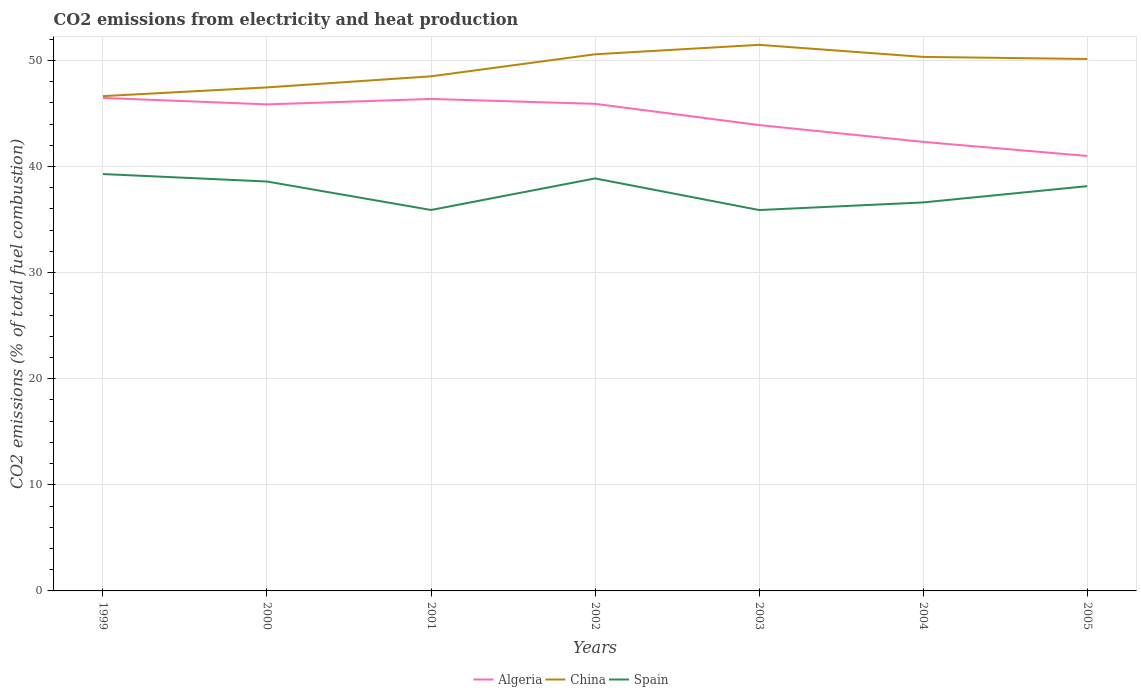How many different coloured lines are there?
Offer a terse response. 3. Across all years, what is the maximum amount of CO2 emitted in China?
Provide a short and direct response. 46.64. In which year was the amount of CO2 emitted in Spain maximum?
Make the answer very short. 2003. What is the total amount of CO2 emitted in China in the graph?
Offer a very short reply. -4.01. What is the difference between the highest and the second highest amount of CO2 emitted in Algeria?
Your response must be concise. 5.47. What is the difference between the highest and the lowest amount of CO2 emitted in China?
Your answer should be very brief. 4. Is the amount of CO2 emitted in China strictly greater than the amount of CO2 emitted in Spain over the years?
Make the answer very short. No. How many years are there in the graph?
Provide a short and direct response. 7. Does the graph contain any zero values?
Make the answer very short. No. Does the graph contain grids?
Make the answer very short. Yes. Where does the legend appear in the graph?
Your answer should be very brief. Bottom center. How many legend labels are there?
Ensure brevity in your answer.  3. How are the legend labels stacked?
Make the answer very short. Horizontal. What is the title of the graph?
Keep it short and to the point. CO2 emissions from electricity and heat production. Does "Moldova" appear as one of the legend labels in the graph?
Provide a succinct answer. No. What is the label or title of the X-axis?
Provide a short and direct response. Years. What is the label or title of the Y-axis?
Keep it short and to the point. CO2 emissions (% of total fuel combustion). What is the CO2 emissions (% of total fuel combustion) of Algeria in 1999?
Keep it short and to the point. 46.47. What is the CO2 emissions (% of total fuel combustion) of China in 1999?
Provide a short and direct response. 46.64. What is the CO2 emissions (% of total fuel combustion) of Spain in 1999?
Give a very brief answer. 39.29. What is the CO2 emissions (% of total fuel combustion) of Algeria in 2000?
Offer a terse response. 45.86. What is the CO2 emissions (% of total fuel combustion) in China in 2000?
Your answer should be very brief. 47.46. What is the CO2 emissions (% of total fuel combustion) of Spain in 2000?
Offer a very short reply. 38.59. What is the CO2 emissions (% of total fuel combustion) of Algeria in 2001?
Offer a very short reply. 46.37. What is the CO2 emissions (% of total fuel combustion) of China in 2001?
Offer a terse response. 48.5. What is the CO2 emissions (% of total fuel combustion) in Spain in 2001?
Provide a short and direct response. 35.91. What is the CO2 emissions (% of total fuel combustion) of Algeria in 2002?
Provide a short and direct response. 45.91. What is the CO2 emissions (% of total fuel combustion) of China in 2002?
Keep it short and to the point. 50.58. What is the CO2 emissions (% of total fuel combustion) in Spain in 2002?
Your answer should be very brief. 38.88. What is the CO2 emissions (% of total fuel combustion) in Algeria in 2003?
Provide a succinct answer. 43.91. What is the CO2 emissions (% of total fuel combustion) of China in 2003?
Give a very brief answer. 51.47. What is the CO2 emissions (% of total fuel combustion) of Spain in 2003?
Give a very brief answer. 35.9. What is the CO2 emissions (% of total fuel combustion) of Algeria in 2004?
Ensure brevity in your answer.  42.32. What is the CO2 emissions (% of total fuel combustion) in China in 2004?
Offer a terse response. 50.33. What is the CO2 emissions (% of total fuel combustion) of Spain in 2004?
Your response must be concise. 36.62. What is the CO2 emissions (% of total fuel combustion) in Algeria in 2005?
Your answer should be compact. 41. What is the CO2 emissions (% of total fuel combustion) of China in 2005?
Ensure brevity in your answer.  50.14. What is the CO2 emissions (% of total fuel combustion) in Spain in 2005?
Give a very brief answer. 38.15. Across all years, what is the maximum CO2 emissions (% of total fuel combustion) in Algeria?
Your response must be concise. 46.47. Across all years, what is the maximum CO2 emissions (% of total fuel combustion) of China?
Offer a terse response. 51.47. Across all years, what is the maximum CO2 emissions (% of total fuel combustion) of Spain?
Make the answer very short. 39.29. Across all years, what is the minimum CO2 emissions (% of total fuel combustion) in Algeria?
Keep it short and to the point. 41. Across all years, what is the minimum CO2 emissions (% of total fuel combustion) in China?
Provide a short and direct response. 46.64. Across all years, what is the minimum CO2 emissions (% of total fuel combustion) of Spain?
Give a very brief answer. 35.9. What is the total CO2 emissions (% of total fuel combustion) of Algeria in the graph?
Make the answer very short. 311.84. What is the total CO2 emissions (% of total fuel combustion) in China in the graph?
Offer a terse response. 345.13. What is the total CO2 emissions (% of total fuel combustion) of Spain in the graph?
Ensure brevity in your answer.  263.34. What is the difference between the CO2 emissions (% of total fuel combustion) in Algeria in 1999 and that in 2000?
Offer a very short reply. 0.61. What is the difference between the CO2 emissions (% of total fuel combustion) of China in 1999 and that in 2000?
Offer a terse response. -0.82. What is the difference between the CO2 emissions (% of total fuel combustion) in Spain in 1999 and that in 2000?
Provide a short and direct response. 0.7. What is the difference between the CO2 emissions (% of total fuel combustion) in Algeria in 1999 and that in 2001?
Your answer should be very brief. 0.1. What is the difference between the CO2 emissions (% of total fuel combustion) of China in 1999 and that in 2001?
Provide a short and direct response. -1.87. What is the difference between the CO2 emissions (% of total fuel combustion) of Spain in 1999 and that in 2001?
Your response must be concise. 3.39. What is the difference between the CO2 emissions (% of total fuel combustion) in Algeria in 1999 and that in 2002?
Your answer should be compact. 0.56. What is the difference between the CO2 emissions (% of total fuel combustion) in China in 1999 and that in 2002?
Ensure brevity in your answer.  -3.94. What is the difference between the CO2 emissions (% of total fuel combustion) of Spain in 1999 and that in 2002?
Your response must be concise. 0.41. What is the difference between the CO2 emissions (% of total fuel combustion) of Algeria in 1999 and that in 2003?
Your answer should be very brief. 2.56. What is the difference between the CO2 emissions (% of total fuel combustion) in China in 1999 and that in 2003?
Your answer should be very brief. -4.83. What is the difference between the CO2 emissions (% of total fuel combustion) in Spain in 1999 and that in 2003?
Give a very brief answer. 3.39. What is the difference between the CO2 emissions (% of total fuel combustion) of Algeria in 1999 and that in 2004?
Make the answer very short. 4.14. What is the difference between the CO2 emissions (% of total fuel combustion) in China in 1999 and that in 2004?
Provide a short and direct response. -3.7. What is the difference between the CO2 emissions (% of total fuel combustion) in Spain in 1999 and that in 2004?
Provide a short and direct response. 2.67. What is the difference between the CO2 emissions (% of total fuel combustion) of Algeria in 1999 and that in 2005?
Keep it short and to the point. 5.47. What is the difference between the CO2 emissions (% of total fuel combustion) of China in 1999 and that in 2005?
Provide a succinct answer. -3.5. What is the difference between the CO2 emissions (% of total fuel combustion) in Spain in 1999 and that in 2005?
Keep it short and to the point. 1.14. What is the difference between the CO2 emissions (% of total fuel combustion) of Algeria in 2000 and that in 2001?
Provide a short and direct response. -0.51. What is the difference between the CO2 emissions (% of total fuel combustion) in China in 2000 and that in 2001?
Give a very brief answer. -1.04. What is the difference between the CO2 emissions (% of total fuel combustion) of Spain in 2000 and that in 2001?
Offer a very short reply. 2.68. What is the difference between the CO2 emissions (% of total fuel combustion) in Algeria in 2000 and that in 2002?
Your answer should be compact. -0.05. What is the difference between the CO2 emissions (% of total fuel combustion) of China in 2000 and that in 2002?
Your response must be concise. -3.12. What is the difference between the CO2 emissions (% of total fuel combustion) of Spain in 2000 and that in 2002?
Your response must be concise. -0.29. What is the difference between the CO2 emissions (% of total fuel combustion) of Algeria in 2000 and that in 2003?
Provide a short and direct response. 1.95. What is the difference between the CO2 emissions (% of total fuel combustion) of China in 2000 and that in 2003?
Offer a terse response. -4.01. What is the difference between the CO2 emissions (% of total fuel combustion) in Spain in 2000 and that in 2003?
Your answer should be compact. 2.69. What is the difference between the CO2 emissions (% of total fuel combustion) in Algeria in 2000 and that in 2004?
Ensure brevity in your answer.  3.53. What is the difference between the CO2 emissions (% of total fuel combustion) in China in 2000 and that in 2004?
Offer a terse response. -2.87. What is the difference between the CO2 emissions (% of total fuel combustion) of Spain in 2000 and that in 2004?
Your answer should be very brief. 1.97. What is the difference between the CO2 emissions (% of total fuel combustion) in Algeria in 2000 and that in 2005?
Keep it short and to the point. 4.86. What is the difference between the CO2 emissions (% of total fuel combustion) in China in 2000 and that in 2005?
Keep it short and to the point. -2.68. What is the difference between the CO2 emissions (% of total fuel combustion) of Spain in 2000 and that in 2005?
Your answer should be very brief. 0.44. What is the difference between the CO2 emissions (% of total fuel combustion) of Algeria in 2001 and that in 2002?
Ensure brevity in your answer.  0.46. What is the difference between the CO2 emissions (% of total fuel combustion) in China in 2001 and that in 2002?
Keep it short and to the point. -2.08. What is the difference between the CO2 emissions (% of total fuel combustion) in Spain in 2001 and that in 2002?
Give a very brief answer. -2.98. What is the difference between the CO2 emissions (% of total fuel combustion) in Algeria in 2001 and that in 2003?
Offer a very short reply. 2.46. What is the difference between the CO2 emissions (% of total fuel combustion) in China in 2001 and that in 2003?
Keep it short and to the point. -2.97. What is the difference between the CO2 emissions (% of total fuel combustion) in Spain in 2001 and that in 2003?
Give a very brief answer. 0. What is the difference between the CO2 emissions (% of total fuel combustion) in Algeria in 2001 and that in 2004?
Keep it short and to the point. 4.05. What is the difference between the CO2 emissions (% of total fuel combustion) in China in 2001 and that in 2004?
Offer a very short reply. -1.83. What is the difference between the CO2 emissions (% of total fuel combustion) in Spain in 2001 and that in 2004?
Your response must be concise. -0.71. What is the difference between the CO2 emissions (% of total fuel combustion) of Algeria in 2001 and that in 2005?
Your answer should be compact. 5.37. What is the difference between the CO2 emissions (% of total fuel combustion) in China in 2001 and that in 2005?
Provide a succinct answer. -1.64. What is the difference between the CO2 emissions (% of total fuel combustion) of Spain in 2001 and that in 2005?
Provide a short and direct response. -2.25. What is the difference between the CO2 emissions (% of total fuel combustion) of Algeria in 2002 and that in 2003?
Give a very brief answer. 2. What is the difference between the CO2 emissions (% of total fuel combustion) in China in 2002 and that in 2003?
Give a very brief answer. -0.89. What is the difference between the CO2 emissions (% of total fuel combustion) of Spain in 2002 and that in 2003?
Give a very brief answer. 2.98. What is the difference between the CO2 emissions (% of total fuel combustion) of Algeria in 2002 and that in 2004?
Your response must be concise. 3.59. What is the difference between the CO2 emissions (% of total fuel combustion) in China in 2002 and that in 2004?
Ensure brevity in your answer.  0.25. What is the difference between the CO2 emissions (% of total fuel combustion) in Spain in 2002 and that in 2004?
Offer a terse response. 2.26. What is the difference between the CO2 emissions (% of total fuel combustion) of Algeria in 2002 and that in 2005?
Provide a succinct answer. 4.91. What is the difference between the CO2 emissions (% of total fuel combustion) of China in 2002 and that in 2005?
Your answer should be very brief. 0.44. What is the difference between the CO2 emissions (% of total fuel combustion) of Spain in 2002 and that in 2005?
Provide a short and direct response. 0.73. What is the difference between the CO2 emissions (% of total fuel combustion) in Algeria in 2003 and that in 2004?
Offer a very short reply. 1.58. What is the difference between the CO2 emissions (% of total fuel combustion) of China in 2003 and that in 2004?
Ensure brevity in your answer.  1.14. What is the difference between the CO2 emissions (% of total fuel combustion) in Spain in 2003 and that in 2004?
Your answer should be compact. -0.72. What is the difference between the CO2 emissions (% of total fuel combustion) of Algeria in 2003 and that in 2005?
Provide a short and direct response. 2.91. What is the difference between the CO2 emissions (% of total fuel combustion) in China in 2003 and that in 2005?
Ensure brevity in your answer.  1.33. What is the difference between the CO2 emissions (% of total fuel combustion) of Spain in 2003 and that in 2005?
Ensure brevity in your answer.  -2.25. What is the difference between the CO2 emissions (% of total fuel combustion) in Algeria in 2004 and that in 2005?
Offer a terse response. 1.33. What is the difference between the CO2 emissions (% of total fuel combustion) in China in 2004 and that in 2005?
Ensure brevity in your answer.  0.19. What is the difference between the CO2 emissions (% of total fuel combustion) in Spain in 2004 and that in 2005?
Offer a very short reply. -1.53. What is the difference between the CO2 emissions (% of total fuel combustion) in Algeria in 1999 and the CO2 emissions (% of total fuel combustion) in China in 2000?
Provide a succinct answer. -0.99. What is the difference between the CO2 emissions (% of total fuel combustion) in Algeria in 1999 and the CO2 emissions (% of total fuel combustion) in Spain in 2000?
Provide a succinct answer. 7.88. What is the difference between the CO2 emissions (% of total fuel combustion) in China in 1999 and the CO2 emissions (% of total fuel combustion) in Spain in 2000?
Make the answer very short. 8.05. What is the difference between the CO2 emissions (% of total fuel combustion) of Algeria in 1999 and the CO2 emissions (% of total fuel combustion) of China in 2001?
Offer a very short reply. -2.04. What is the difference between the CO2 emissions (% of total fuel combustion) in Algeria in 1999 and the CO2 emissions (% of total fuel combustion) in Spain in 2001?
Your answer should be compact. 10.56. What is the difference between the CO2 emissions (% of total fuel combustion) of China in 1999 and the CO2 emissions (% of total fuel combustion) of Spain in 2001?
Offer a very short reply. 10.73. What is the difference between the CO2 emissions (% of total fuel combustion) in Algeria in 1999 and the CO2 emissions (% of total fuel combustion) in China in 2002?
Make the answer very short. -4.11. What is the difference between the CO2 emissions (% of total fuel combustion) in Algeria in 1999 and the CO2 emissions (% of total fuel combustion) in Spain in 2002?
Provide a short and direct response. 7.59. What is the difference between the CO2 emissions (% of total fuel combustion) of China in 1999 and the CO2 emissions (% of total fuel combustion) of Spain in 2002?
Make the answer very short. 7.76. What is the difference between the CO2 emissions (% of total fuel combustion) in Algeria in 1999 and the CO2 emissions (% of total fuel combustion) in China in 2003?
Offer a very short reply. -5. What is the difference between the CO2 emissions (% of total fuel combustion) of Algeria in 1999 and the CO2 emissions (% of total fuel combustion) of Spain in 2003?
Provide a short and direct response. 10.57. What is the difference between the CO2 emissions (% of total fuel combustion) in China in 1999 and the CO2 emissions (% of total fuel combustion) in Spain in 2003?
Make the answer very short. 10.74. What is the difference between the CO2 emissions (% of total fuel combustion) of Algeria in 1999 and the CO2 emissions (% of total fuel combustion) of China in 2004?
Provide a short and direct response. -3.87. What is the difference between the CO2 emissions (% of total fuel combustion) of Algeria in 1999 and the CO2 emissions (% of total fuel combustion) of Spain in 2004?
Make the answer very short. 9.85. What is the difference between the CO2 emissions (% of total fuel combustion) in China in 1999 and the CO2 emissions (% of total fuel combustion) in Spain in 2004?
Make the answer very short. 10.02. What is the difference between the CO2 emissions (% of total fuel combustion) in Algeria in 1999 and the CO2 emissions (% of total fuel combustion) in China in 2005?
Keep it short and to the point. -3.67. What is the difference between the CO2 emissions (% of total fuel combustion) of Algeria in 1999 and the CO2 emissions (% of total fuel combustion) of Spain in 2005?
Your answer should be compact. 8.31. What is the difference between the CO2 emissions (% of total fuel combustion) in China in 1999 and the CO2 emissions (% of total fuel combustion) in Spain in 2005?
Your answer should be very brief. 8.48. What is the difference between the CO2 emissions (% of total fuel combustion) in Algeria in 2000 and the CO2 emissions (% of total fuel combustion) in China in 2001?
Your response must be concise. -2.64. What is the difference between the CO2 emissions (% of total fuel combustion) of Algeria in 2000 and the CO2 emissions (% of total fuel combustion) of Spain in 2001?
Make the answer very short. 9.95. What is the difference between the CO2 emissions (% of total fuel combustion) in China in 2000 and the CO2 emissions (% of total fuel combustion) in Spain in 2001?
Your answer should be compact. 11.56. What is the difference between the CO2 emissions (% of total fuel combustion) of Algeria in 2000 and the CO2 emissions (% of total fuel combustion) of China in 2002?
Give a very brief answer. -4.72. What is the difference between the CO2 emissions (% of total fuel combustion) in Algeria in 2000 and the CO2 emissions (% of total fuel combustion) in Spain in 2002?
Offer a terse response. 6.98. What is the difference between the CO2 emissions (% of total fuel combustion) in China in 2000 and the CO2 emissions (% of total fuel combustion) in Spain in 2002?
Make the answer very short. 8.58. What is the difference between the CO2 emissions (% of total fuel combustion) of Algeria in 2000 and the CO2 emissions (% of total fuel combustion) of China in 2003?
Keep it short and to the point. -5.61. What is the difference between the CO2 emissions (% of total fuel combustion) in Algeria in 2000 and the CO2 emissions (% of total fuel combustion) in Spain in 2003?
Your response must be concise. 9.96. What is the difference between the CO2 emissions (% of total fuel combustion) of China in 2000 and the CO2 emissions (% of total fuel combustion) of Spain in 2003?
Your response must be concise. 11.56. What is the difference between the CO2 emissions (% of total fuel combustion) in Algeria in 2000 and the CO2 emissions (% of total fuel combustion) in China in 2004?
Offer a terse response. -4.47. What is the difference between the CO2 emissions (% of total fuel combustion) in Algeria in 2000 and the CO2 emissions (% of total fuel combustion) in Spain in 2004?
Your answer should be very brief. 9.24. What is the difference between the CO2 emissions (% of total fuel combustion) of China in 2000 and the CO2 emissions (% of total fuel combustion) of Spain in 2004?
Offer a very short reply. 10.84. What is the difference between the CO2 emissions (% of total fuel combustion) of Algeria in 2000 and the CO2 emissions (% of total fuel combustion) of China in 2005?
Make the answer very short. -4.28. What is the difference between the CO2 emissions (% of total fuel combustion) in Algeria in 2000 and the CO2 emissions (% of total fuel combustion) in Spain in 2005?
Keep it short and to the point. 7.71. What is the difference between the CO2 emissions (% of total fuel combustion) of China in 2000 and the CO2 emissions (% of total fuel combustion) of Spain in 2005?
Your response must be concise. 9.31. What is the difference between the CO2 emissions (% of total fuel combustion) of Algeria in 2001 and the CO2 emissions (% of total fuel combustion) of China in 2002?
Provide a succinct answer. -4.21. What is the difference between the CO2 emissions (% of total fuel combustion) in Algeria in 2001 and the CO2 emissions (% of total fuel combustion) in Spain in 2002?
Your answer should be very brief. 7.49. What is the difference between the CO2 emissions (% of total fuel combustion) of China in 2001 and the CO2 emissions (% of total fuel combustion) of Spain in 2002?
Your answer should be compact. 9.62. What is the difference between the CO2 emissions (% of total fuel combustion) of Algeria in 2001 and the CO2 emissions (% of total fuel combustion) of China in 2003?
Give a very brief answer. -5.1. What is the difference between the CO2 emissions (% of total fuel combustion) in Algeria in 2001 and the CO2 emissions (% of total fuel combustion) in Spain in 2003?
Your answer should be compact. 10.47. What is the difference between the CO2 emissions (% of total fuel combustion) of China in 2001 and the CO2 emissions (% of total fuel combustion) of Spain in 2003?
Offer a terse response. 12.6. What is the difference between the CO2 emissions (% of total fuel combustion) in Algeria in 2001 and the CO2 emissions (% of total fuel combustion) in China in 2004?
Ensure brevity in your answer.  -3.96. What is the difference between the CO2 emissions (% of total fuel combustion) of Algeria in 2001 and the CO2 emissions (% of total fuel combustion) of Spain in 2004?
Your answer should be compact. 9.75. What is the difference between the CO2 emissions (% of total fuel combustion) of China in 2001 and the CO2 emissions (% of total fuel combustion) of Spain in 2004?
Keep it short and to the point. 11.89. What is the difference between the CO2 emissions (% of total fuel combustion) of Algeria in 2001 and the CO2 emissions (% of total fuel combustion) of China in 2005?
Your answer should be compact. -3.77. What is the difference between the CO2 emissions (% of total fuel combustion) of Algeria in 2001 and the CO2 emissions (% of total fuel combustion) of Spain in 2005?
Make the answer very short. 8.22. What is the difference between the CO2 emissions (% of total fuel combustion) in China in 2001 and the CO2 emissions (% of total fuel combustion) in Spain in 2005?
Keep it short and to the point. 10.35. What is the difference between the CO2 emissions (% of total fuel combustion) in Algeria in 2002 and the CO2 emissions (% of total fuel combustion) in China in 2003?
Make the answer very short. -5.56. What is the difference between the CO2 emissions (% of total fuel combustion) in Algeria in 2002 and the CO2 emissions (% of total fuel combustion) in Spain in 2003?
Offer a terse response. 10.01. What is the difference between the CO2 emissions (% of total fuel combustion) of China in 2002 and the CO2 emissions (% of total fuel combustion) of Spain in 2003?
Provide a short and direct response. 14.68. What is the difference between the CO2 emissions (% of total fuel combustion) of Algeria in 2002 and the CO2 emissions (% of total fuel combustion) of China in 2004?
Give a very brief answer. -4.42. What is the difference between the CO2 emissions (% of total fuel combustion) of Algeria in 2002 and the CO2 emissions (% of total fuel combustion) of Spain in 2004?
Your answer should be very brief. 9.29. What is the difference between the CO2 emissions (% of total fuel combustion) of China in 2002 and the CO2 emissions (% of total fuel combustion) of Spain in 2004?
Ensure brevity in your answer.  13.96. What is the difference between the CO2 emissions (% of total fuel combustion) of Algeria in 2002 and the CO2 emissions (% of total fuel combustion) of China in 2005?
Offer a very short reply. -4.23. What is the difference between the CO2 emissions (% of total fuel combustion) of Algeria in 2002 and the CO2 emissions (% of total fuel combustion) of Spain in 2005?
Your answer should be very brief. 7.76. What is the difference between the CO2 emissions (% of total fuel combustion) in China in 2002 and the CO2 emissions (% of total fuel combustion) in Spain in 2005?
Your answer should be compact. 12.43. What is the difference between the CO2 emissions (% of total fuel combustion) in Algeria in 2003 and the CO2 emissions (% of total fuel combustion) in China in 2004?
Your answer should be compact. -6.42. What is the difference between the CO2 emissions (% of total fuel combustion) of Algeria in 2003 and the CO2 emissions (% of total fuel combustion) of Spain in 2004?
Provide a succinct answer. 7.29. What is the difference between the CO2 emissions (% of total fuel combustion) in China in 2003 and the CO2 emissions (% of total fuel combustion) in Spain in 2004?
Your response must be concise. 14.85. What is the difference between the CO2 emissions (% of total fuel combustion) in Algeria in 2003 and the CO2 emissions (% of total fuel combustion) in China in 2005?
Your response must be concise. -6.23. What is the difference between the CO2 emissions (% of total fuel combustion) of Algeria in 2003 and the CO2 emissions (% of total fuel combustion) of Spain in 2005?
Your answer should be very brief. 5.76. What is the difference between the CO2 emissions (% of total fuel combustion) in China in 2003 and the CO2 emissions (% of total fuel combustion) in Spain in 2005?
Keep it short and to the point. 13.32. What is the difference between the CO2 emissions (% of total fuel combustion) of Algeria in 2004 and the CO2 emissions (% of total fuel combustion) of China in 2005?
Your answer should be very brief. -7.82. What is the difference between the CO2 emissions (% of total fuel combustion) in Algeria in 2004 and the CO2 emissions (% of total fuel combustion) in Spain in 2005?
Offer a terse response. 4.17. What is the difference between the CO2 emissions (% of total fuel combustion) of China in 2004 and the CO2 emissions (% of total fuel combustion) of Spain in 2005?
Make the answer very short. 12.18. What is the average CO2 emissions (% of total fuel combustion) in Algeria per year?
Give a very brief answer. 44.55. What is the average CO2 emissions (% of total fuel combustion) in China per year?
Make the answer very short. 49.3. What is the average CO2 emissions (% of total fuel combustion) of Spain per year?
Your response must be concise. 37.62. In the year 1999, what is the difference between the CO2 emissions (% of total fuel combustion) in Algeria and CO2 emissions (% of total fuel combustion) in China?
Your response must be concise. -0.17. In the year 1999, what is the difference between the CO2 emissions (% of total fuel combustion) in Algeria and CO2 emissions (% of total fuel combustion) in Spain?
Offer a terse response. 7.17. In the year 1999, what is the difference between the CO2 emissions (% of total fuel combustion) of China and CO2 emissions (% of total fuel combustion) of Spain?
Your response must be concise. 7.34. In the year 2000, what is the difference between the CO2 emissions (% of total fuel combustion) of Algeria and CO2 emissions (% of total fuel combustion) of China?
Ensure brevity in your answer.  -1.6. In the year 2000, what is the difference between the CO2 emissions (% of total fuel combustion) of Algeria and CO2 emissions (% of total fuel combustion) of Spain?
Provide a succinct answer. 7.27. In the year 2000, what is the difference between the CO2 emissions (% of total fuel combustion) in China and CO2 emissions (% of total fuel combustion) in Spain?
Provide a short and direct response. 8.87. In the year 2001, what is the difference between the CO2 emissions (% of total fuel combustion) in Algeria and CO2 emissions (% of total fuel combustion) in China?
Ensure brevity in your answer.  -2.13. In the year 2001, what is the difference between the CO2 emissions (% of total fuel combustion) in Algeria and CO2 emissions (% of total fuel combustion) in Spain?
Provide a short and direct response. 10.47. In the year 2001, what is the difference between the CO2 emissions (% of total fuel combustion) of China and CO2 emissions (% of total fuel combustion) of Spain?
Offer a terse response. 12.6. In the year 2002, what is the difference between the CO2 emissions (% of total fuel combustion) of Algeria and CO2 emissions (% of total fuel combustion) of China?
Your answer should be very brief. -4.67. In the year 2002, what is the difference between the CO2 emissions (% of total fuel combustion) of Algeria and CO2 emissions (% of total fuel combustion) of Spain?
Provide a short and direct response. 7.03. In the year 2002, what is the difference between the CO2 emissions (% of total fuel combustion) of China and CO2 emissions (% of total fuel combustion) of Spain?
Ensure brevity in your answer.  11.7. In the year 2003, what is the difference between the CO2 emissions (% of total fuel combustion) in Algeria and CO2 emissions (% of total fuel combustion) in China?
Your answer should be compact. -7.56. In the year 2003, what is the difference between the CO2 emissions (% of total fuel combustion) of Algeria and CO2 emissions (% of total fuel combustion) of Spain?
Your answer should be compact. 8.01. In the year 2003, what is the difference between the CO2 emissions (% of total fuel combustion) of China and CO2 emissions (% of total fuel combustion) of Spain?
Your answer should be very brief. 15.57. In the year 2004, what is the difference between the CO2 emissions (% of total fuel combustion) in Algeria and CO2 emissions (% of total fuel combustion) in China?
Provide a succinct answer. -8.01. In the year 2004, what is the difference between the CO2 emissions (% of total fuel combustion) of Algeria and CO2 emissions (% of total fuel combustion) of Spain?
Keep it short and to the point. 5.71. In the year 2004, what is the difference between the CO2 emissions (% of total fuel combustion) of China and CO2 emissions (% of total fuel combustion) of Spain?
Provide a short and direct response. 13.71. In the year 2005, what is the difference between the CO2 emissions (% of total fuel combustion) of Algeria and CO2 emissions (% of total fuel combustion) of China?
Offer a very short reply. -9.14. In the year 2005, what is the difference between the CO2 emissions (% of total fuel combustion) of Algeria and CO2 emissions (% of total fuel combustion) of Spain?
Your answer should be very brief. 2.85. In the year 2005, what is the difference between the CO2 emissions (% of total fuel combustion) of China and CO2 emissions (% of total fuel combustion) of Spain?
Keep it short and to the point. 11.99. What is the ratio of the CO2 emissions (% of total fuel combustion) of Algeria in 1999 to that in 2000?
Give a very brief answer. 1.01. What is the ratio of the CO2 emissions (% of total fuel combustion) of China in 1999 to that in 2000?
Offer a very short reply. 0.98. What is the ratio of the CO2 emissions (% of total fuel combustion) of Spain in 1999 to that in 2000?
Offer a terse response. 1.02. What is the ratio of the CO2 emissions (% of total fuel combustion) in Algeria in 1999 to that in 2001?
Provide a short and direct response. 1. What is the ratio of the CO2 emissions (% of total fuel combustion) of China in 1999 to that in 2001?
Give a very brief answer. 0.96. What is the ratio of the CO2 emissions (% of total fuel combustion) of Spain in 1999 to that in 2001?
Ensure brevity in your answer.  1.09. What is the ratio of the CO2 emissions (% of total fuel combustion) of Algeria in 1999 to that in 2002?
Your answer should be very brief. 1.01. What is the ratio of the CO2 emissions (% of total fuel combustion) of China in 1999 to that in 2002?
Offer a terse response. 0.92. What is the ratio of the CO2 emissions (% of total fuel combustion) in Spain in 1999 to that in 2002?
Provide a succinct answer. 1.01. What is the ratio of the CO2 emissions (% of total fuel combustion) in Algeria in 1999 to that in 2003?
Provide a succinct answer. 1.06. What is the ratio of the CO2 emissions (% of total fuel combustion) in China in 1999 to that in 2003?
Offer a terse response. 0.91. What is the ratio of the CO2 emissions (% of total fuel combustion) in Spain in 1999 to that in 2003?
Provide a short and direct response. 1.09. What is the ratio of the CO2 emissions (% of total fuel combustion) of Algeria in 1999 to that in 2004?
Provide a succinct answer. 1.1. What is the ratio of the CO2 emissions (% of total fuel combustion) of China in 1999 to that in 2004?
Your answer should be compact. 0.93. What is the ratio of the CO2 emissions (% of total fuel combustion) of Spain in 1999 to that in 2004?
Keep it short and to the point. 1.07. What is the ratio of the CO2 emissions (% of total fuel combustion) of Algeria in 1999 to that in 2005?
Ensure brevity in your answer.  1.13. What is the ratio of the CO2 emissions (% of total fuel combustion) in China in 1999 to that in 2005?
Your answer should be compact. 0.93. What is the ratio of the CO2 emissions (% of total fuel combustion) of Spain in 1999 to that in 2005?
Your answer should be compact. 1.03. What is the ratio of the CO2 emissions (% of total fuel combustion) in China in 2000 to that in 2001?
Make the answer very short. 0.98. What is the ratio of the CO2 emissions (% of total fuel combustion) in Spain in 2000 to that in 2001?
Offer a very short reply. 1.07. What is the ratio of the CO2 emissions (% of total fuel combustion) of Algeria in 2000 to that in 2002?
Your response must be concise. 1. What is the ratio of the CO2 emissions (% of total fuel combustion) in China in 2000 to that in 2002?
Your answer should be compact. 0.94. What is the ratio of the CO2 emissions (% of total fuel combustion) of Spain in 2000 to that in 2002?
Provide a short and direct response. 0.99. What is the ratio of the CO2 emissions (% of total fuel combustion) in Algeria in 2000 to that in 2003?
Your response must be concise. 1.04. What is the ratio of the CO2 emissions (% of total fuel combustion) of China in 2000 to that in 2003?
Provide a short and direct response. 0.92. What is the ratio of the CO2 emissions (% of total fuel combustion) in Spain in 2000 to that in 2003?
Give a very brief answer. 1.07. What is the ratio of the CO2 emissions (% of total fuel combustion) in Algeria in 2000 to that in 2004?
Your answer should be compact. 1.08. What is the ratio of the CO2 emissions (% of total fuel combustion) in China in 2000 to that in 2004?
Offer a terse response. 0.94. What is the ratio of the CO2 emissions (% of total fuel combustion) in Spain in 2000 to that in 2004?
Keep it short and to the point. 1.05. What is the ratio of the CO2 emissions (% of total fuel combustion) of Algeria in 2000 to that in 2005?
Your answer should be very brief. 1.12. What is the ratio of the CO2 emissions (% of total fuel combustion) of China in 2000 to that in 2005?
Your answer should be very brief. 0.95. What is the ratio of the CO2 emissions (% of total fuel combustion) of Spain in 2000 to that in 2005?
Provide a succinct answer. 1.01. What is the ratio of the CO2 emissions (% of total fuel combustion) in Algeria in 2001 to that in 2002?
Offer a very short reply. 1.01. What is the ratio of the CO2 emissions (% of total fuel combustion) in China in 2001 to that in 2002?
Offer a terse response. 0.96. What is the ratio of the CO2 emissions (% of total fuel combustion) of Spain in 2001 to that in 2002?
Keep it short and to the point. 0.92. What is the ratio of the CO2 emissions (% of total fuel combustion) in Algeria in 2001 to that in 2003?
Provide a short and direct response. 1.06. What is the ratio of the CO2 emissions (% of total fuel combustion) of China in 2001 to that in 2003?
Offer a very short reply. 0.94. What is the ratio of the CO2 emissions (% of total fuel combustion) of Algeria in 2001 to that in 2004?
Your response must be concise. 1.1. What is the ratio of the CO2 emissions (% of total fuel combustion) in China in 2001 to that in 2004?
Your response must be concise. 0.96. What is the ratio of the CO2 emissions (% of total fuel combustion) in Spain in 2001 to that in 2004?
Your response must be concise. 0.98. What is the ratio of the CO2 emissions (% of total fuel combustion) in Algeria in 2001 to that in 2005?
Your answer should be very brief. 1.13. What is the ratio of the CO2 emissions (% of total fuel combustion) of China in 2001 to that in 2005?
Your response must be concise. 0.97. What is the ratio of the CO2 emissions (% of total fuel combustion) in Spain in 2001 to that in 2005?
Make the answer very short. 0.94. What is the ratio of the CO2 emissions (% of total fuel combustion) in Algeria in 2002 to that in 2003?
Provide a short and direct response. 1.05. What is the ratio of the CO2 emissions (% of total fuel combustion) in China in 2002 to that in 2003?
Keep it short and to the point. 0.98. What is the ratio of the CO2 emissions (% of total fuel combustion) in Spain in 2002 to that in 2003?
Your answer should be compact. 1.08. What is the ratio of the CO2 emissions (% of total fuel combustion) in Algeria in 2002 to that in 2004?
Keep it short and to the point. 1.08. What is the ratio of the CO2 emissions (% of total fuel combustion) in Spain in 2002 to that in 2004?
Offer a very short reply. 1.06. What is the ratio of the CO2 emissions (% of total fuel combustion) in Algeria in 2002 to that in 2005?
Your response must be concise. 1.12. What is the ratio of the CO2 emissions (% of total fuel combustion) in China in 2002 to that in 2005?
Offer a very short reply. 1.01. What is the ratio of the CO2 emissions (% of total fuel combustion) in Spain in 2002 to that in 2005?
Offer a very short reply. 1.02. What is the ratio of the CO2 emissions (% of total fuel combustion) of Algeria in 2003 to that in 2004?
Provide a short and direct response. 1.04. What is the ratio of the CO2 emissions (% of total fuel combustion) in China in 2003 to that in 2004?
Offer a terse response. 1.02. What is the ratio of the CO2 emissions (% of total fuel combustion) of Spain in 2003 to that in 2004?
Keep it short and to the point. 0.98. What is the ratio of the CO2 emissions (% of total fuel combustion) in Algeria in 2003 to that in 2005?
Offer a very short reply. 1.07. What is the ratio of the CO2 emissions (% of total fuel combustion) of China in 2003 to that in 2005?
Give a very brief answer. 1.03. What is the ratio of the CO2 emissions (% of total fuel combustion) in Spain in 2003 to that in 2005?
Your answer should be compact. 0.94. What is the ratio of the CO2 emissions (% of total fuel combustion) in Algeria in 2004 to that in 2005?
Give a very brief answer. 1.03. What is the ratio of the CO2 emissions (% of total fuel combustion) in China in 2004 to that in 2005?
Give a very brief answer. 1. What is the ratio of the CO2 emissions (% of total fuel combustion) of Spain in 2004 to that in 2005?
Make the answer very short. 0.96. What is the difference between the highest and the second highest CO2 emissions (% of total fuel combustion) of Algeria?
Give a very brief answer. 0.1. What is the difference between the highest and the second highest CO2 emissions (% of total fuel combustion) in China?
Provide a short and direct response. 0.89. What is the difference between the highest and the second highest CO2 emissions (% of total fuel combustion) of Spain?
Your answer should be compact. 0.41. What is the difference between the highest and the lowest CO2 emissions (% of total fuel combustion) of Algeria?
Keep it short and to the point. 5.47. What is the difference between the highest and the lowest CO2 emissions (% of total fuel combustion) of China?
Provide a succinct answer. 4.83. What is the difference between the highest and the lowest CO2 emissions (% of total fuel combustion) in Spain?
Provide a short and direct response. 3.39. 